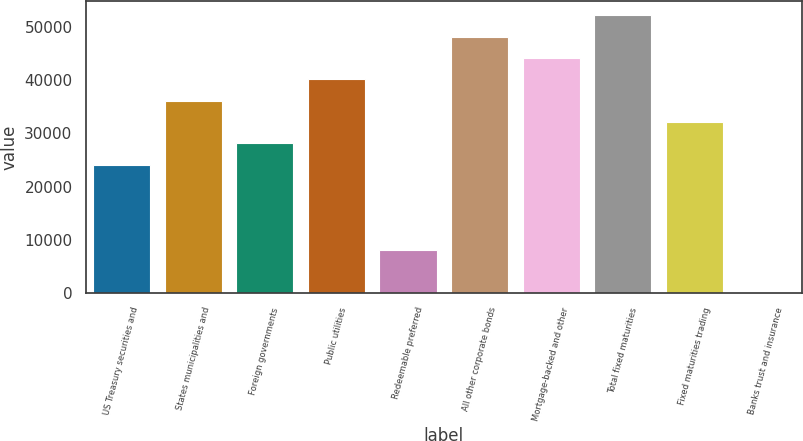Convert chart. <chart><loc_0><loc_0><loc_500><loc_500><bar_chart><fcel>US Treasury securities and<fcel>States municipalities and<fcel>Foreign governments<fcel>Public utilities<fcel>Redeemable preferred<fcel>All other corporate bonds<fcel>Mortgage-backed and other<fcel>Total fixed maturities<fcel>Fixed maturities trading<fcel>Banks trust and insurance<nl><fcel>24070.6<fcel>36105.5<fcel>28082.2<fcel>40117.2<fcel>8023.92<fcel>48140.5<fcel>44128.9<fcel>52152.2<fcel>32093.9<fcel>0.6<nl></chart> 